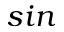Convert formula to latex. <formula><loc_0><loc_0><loc_500><loc_500>\sin</formula> 